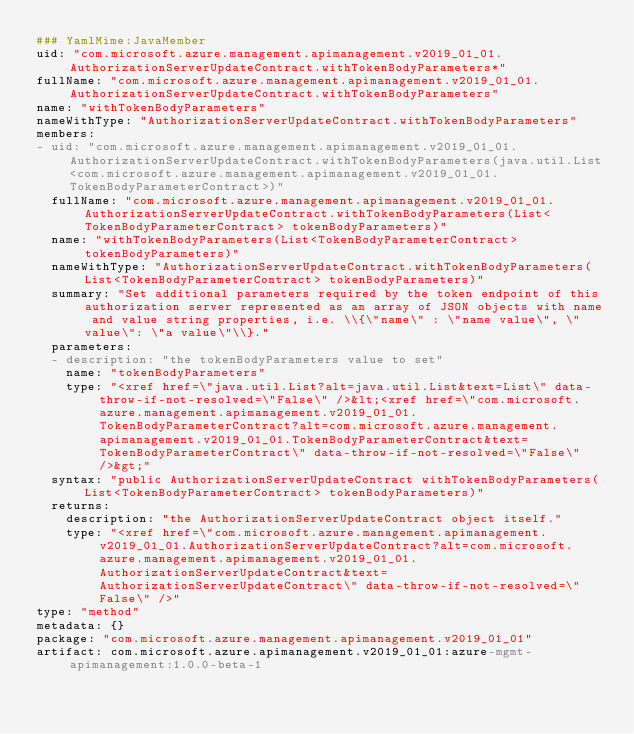Convert code to text. <code><loc_0><loc_0><loc_500><loc_500><_YAML_>### YamlMime:JavaMember
uid: "com.microsoft.azure.management.apimanagement.v2019_01_01.AuthorizationServerUpdateContract.withTokenBodyParameters*"
fullName: "com.microsoft.azure.management.apimanagement.v2019_01_01.AuthorizationServerUpdateContract.withTokenBodyParameters"
name: "withTokenBodyParameters"
nameWithType: "AuthorizationServerUpdateContract.withTokenBodyParameters"
members:
- uid: "com.microsoft.azure.management.apimanagement.v2019_01_01.AuthorizationServerUpdateContract.withTokenBodyParameters(java.util.List<com.microsoft.azure.management.apimanagement.v2019_01_01.TokenBodyParameterContract>)"
  fullName: "com.microsoft.azure.management.apimanagement.v2019_01_01.AuthorizationServerUpdateContract.withTokenBodyParameters(List<TokenBodyParameterContract> tokenBodyParameters)"
  name: "withTokenBodyParameters(List<TokenBodyParameterContract> tokenBodyParameters)"
  nameWithType: "AuthorizationServerUpdateContract.withTokenBodyParameters(List<TokenBodyParameterContract> tokenBodyParameters)"
  summary: "Set additional parameters required by the token endpoint of this authorization server represented as an array of JSON objects with name and value string properties, i.e. \\{\"name\" : \"name value\", \"value\": \"a value\"\\}."
  parameters:
  - description: "the tokenBodyParameters value to set"
    name: "tokenBodyParameters"
    type: "<xref href=\"java.util.List?alt=java.util.List&text=List\" data-throw-if-not-resolved=\"False\" />&lt;<xref href=\"com.microsoft.azure.management.apimanagement.v2019_01_01.TokenBodyParameterContract?alt=com.microsoft.azure.management.apimanagement.v2019_01_01.TokenBodyParameterContract&text=TokenBodyParameterContract\" data-throw-if-not-resolved=\"False\" />&gt;"
  syntax: "public AuthorizationServerUpdateContract withTokenBodyParameters(List<TokenBodyParameterContract> tokenBodyParameters)"
  returns:
    description: "the AuthorizationServerUpdateContract object itself."
    type: "<xref href=\"com.microsoft.azure.management.apimanagement.v2019_01_01.AuthorizationServerUpdateContract?alt=com.microsoft.azure.management.apimanagement.v2019_01_01.AuthorizationServerUpdateContract&text=AuthorizationServerUpdateContract\" data-throw-if-not-resolved=\"False\" />"
type: "method"
metadata: {}
package: "com.microsoft.azure.management.apimanagement.v2019_01_01"
artifact: com.microsoft.azure.apimanagement.v2019_01_01:azure-mgmt-apimanagement:1.0.0-beta-1
</code> 